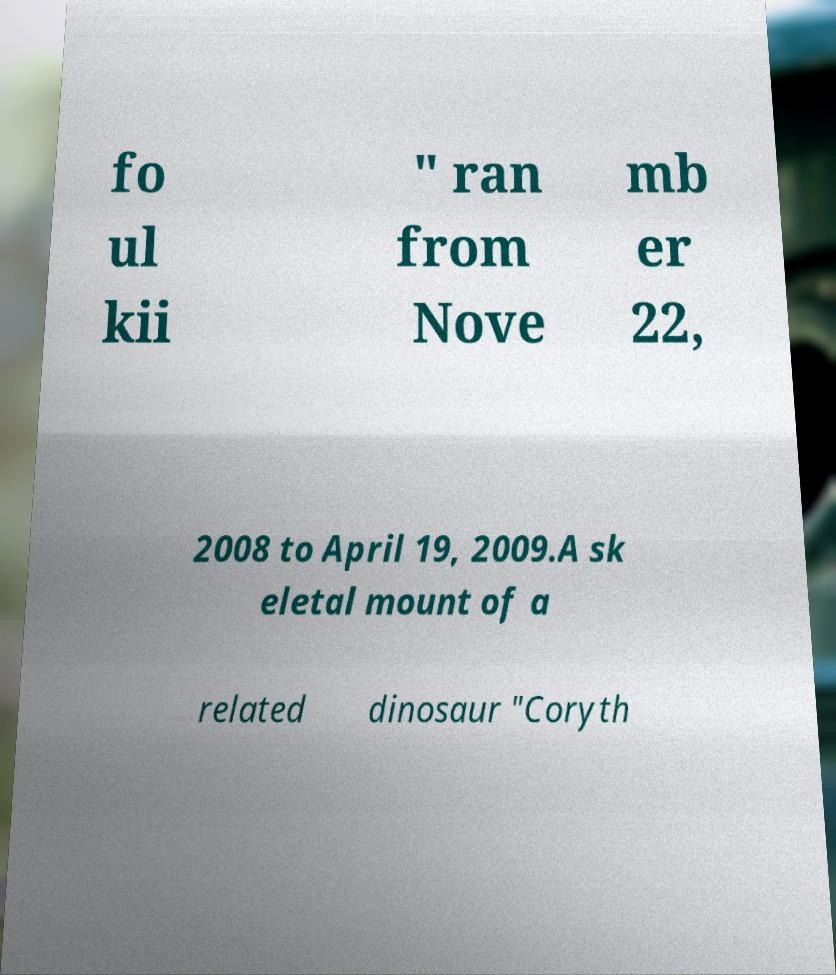I need the written content from this picture converted into text. Can you do that? fo ul kii " ran from Nove mb er 22, 2008 to April 19, 2009.A sk eletal mount of a related dinosaur "Coryth 